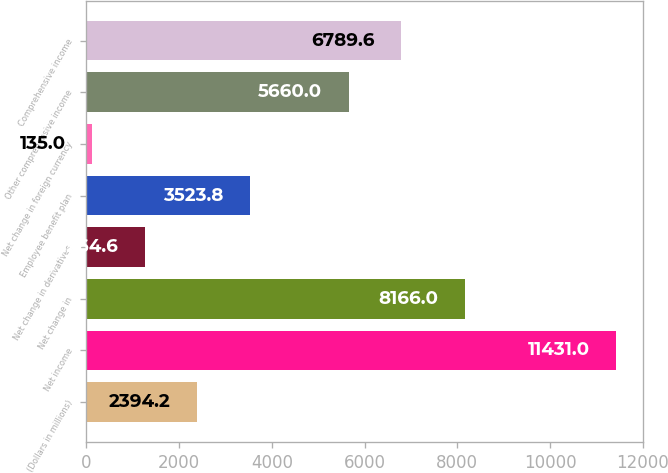<chart> <loc_0><loc_0><loc_500><loc_500><bar_chart><fcel>(Dollars in millions)<fcel>Net income<fcel>Net change in<fcel>Net change in derivatives<fcel>Employee benefit plan<fcel>Net change in foreign currency<fcel>Other comprehensive income<fcel>Comprehensive income<nl><fcel>2394.2<fcel>11431<fcel>8166<fcel>1264.6<fcel>3523.8<fcel>135<fcel>5660<fcel>6789.6<nl></chart> 